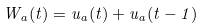<formula> <loc_0><loc_0><loc_500><loc_500>W _ { a } ( t ) = u _ { a } ( t ) + u _ { a } ( t - 1 )</formula> 